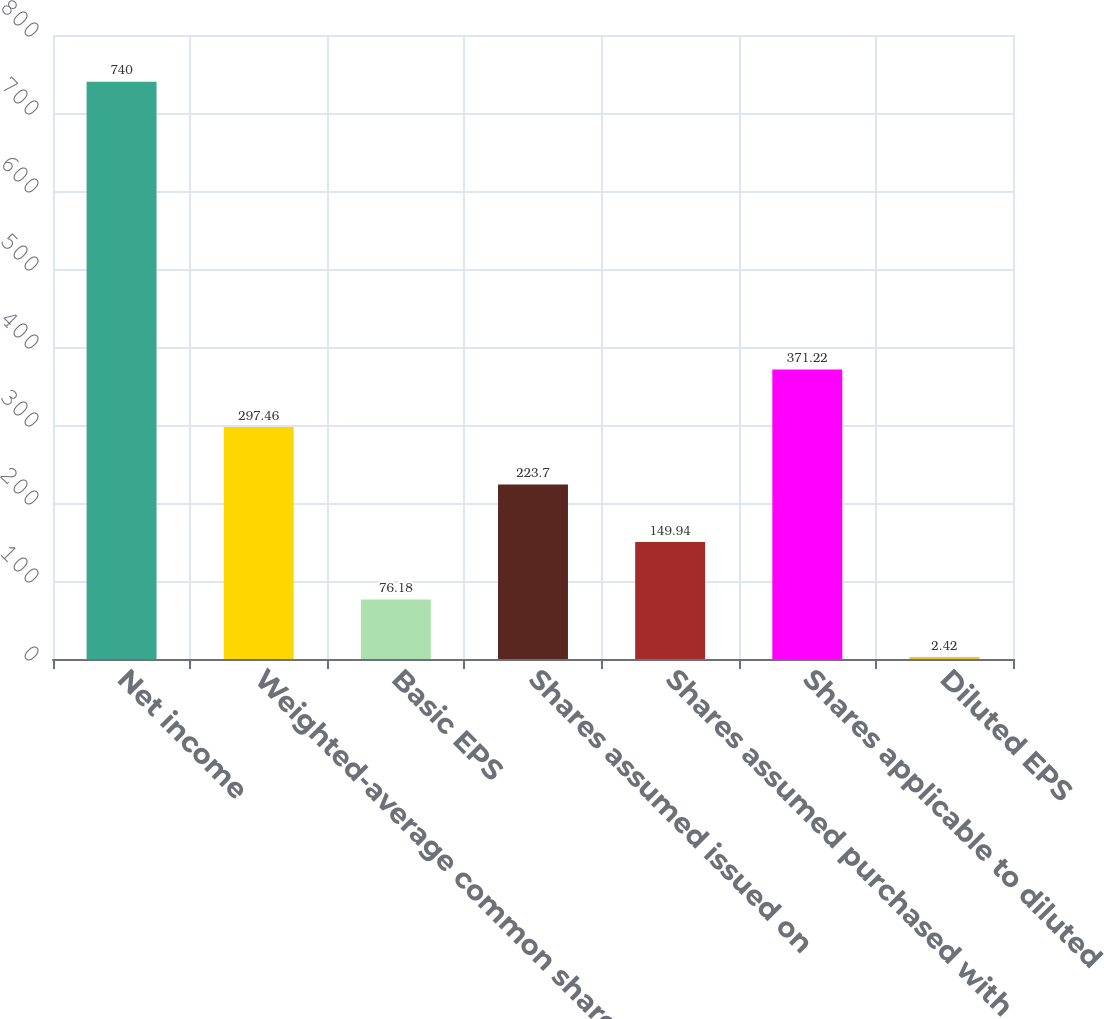<chart> <loc_0><loc_0><loc_500><loc_500><bar_chart><fcel>Net income<fcel>Weighted-average common shares<fcel>Basic EPS<fcel>Shares assumed issued on<fcel>Shares assumed purchased with<fcel>Shares applicable to diluted<fcel>Diluted EPS<nl><fcel>740<fcel>297.46<fcel>76.18<fcel>223.7<fcel>149.94<fcel>371.22<fcel>2.42<nl></chart> 